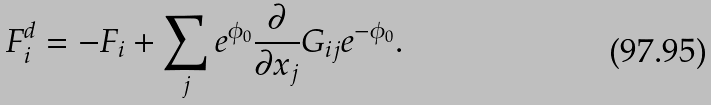Convert formula to latex. <formula><loc_0><loc_0><loc_500><loc_500>F _ { i } ^ { d } = - F _ { i } + \sum _ { j } e ^ { \phi _ { 0 } } \frac { \partial } { \partial x _ { j } } G _ { i j } e ^ { - \phi _ { 0 } } .</formula> 